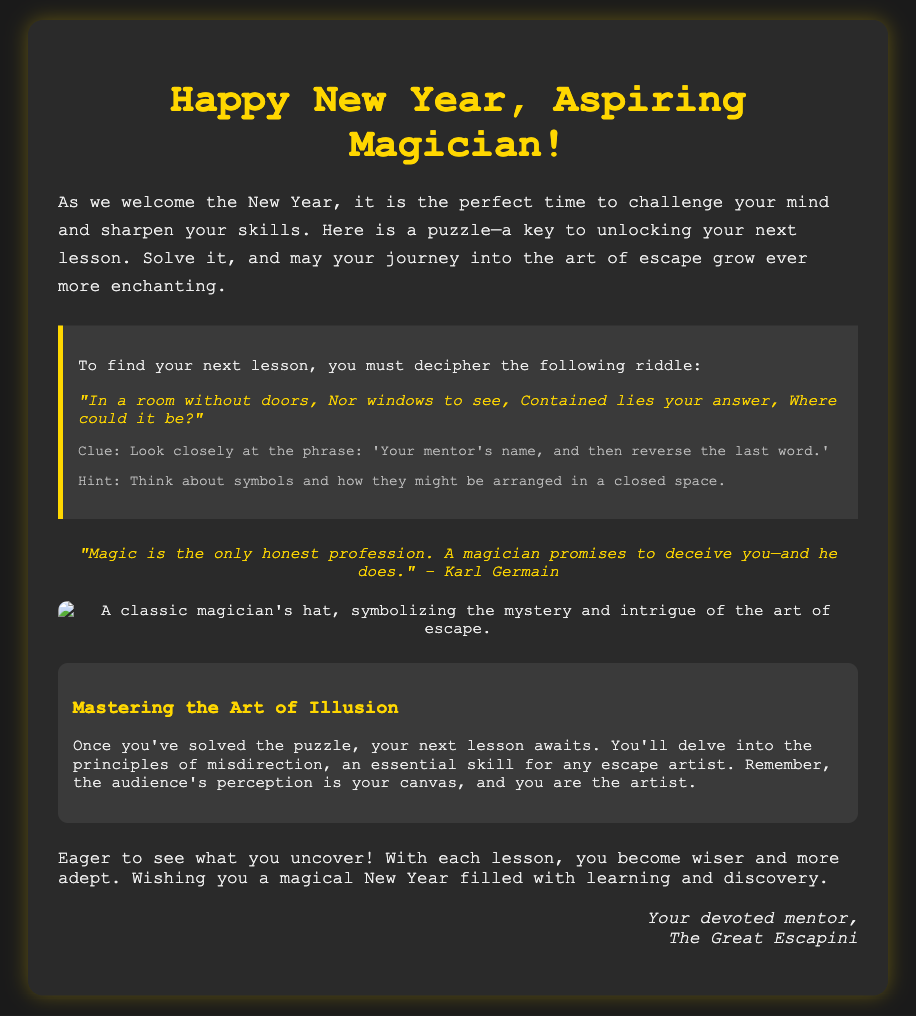What is the title of the card? The title is prominently displayed at the top of the card in large font.
Answer: Happy New Year, Aspiring Magician! What is the riddle presented in the puzzle? The riddle is found within the puzzle section of the card which challenges the reader.
Answer: "In a room without doors, Nor windows to see, Contained lies your answer, Where could it be?" What is the clue provided for solving the puzzle? The clue is meant to assist in deciphering the riddle presented earlier.
Answer: Look closely at the phrase: 'Your mentor's name, and then reverse the last word.' What is the quote included in the card? The quote is attributed to a well-known magician and adds depth to the card's message.
Answer: "Magic is the only honest profession. A magician promises to deceive you—and he does." – Karl Germain What lesson is mentioned after solving the puzzle? This lesson is the next step for the reader upon solving the challenge.
Answer: Mastering the Art of Illusion What is the color of the card’s background? The background color is essential for setting the overall tone of the card.
Answer: #1a1a1a Who is the signoff from? The signoff gives a personal touch and identifies the author of the message.
Answer: The Great Escapini What is the hint related to solving the puzzle? The hint serves as additional guidance for deciphering the riddle effectively.
Answer: Think about symbols and how they might be arranged in a closed space What image is included in the card? The image enhances the visual appeal and relates to the theme of the card.
Answer: A classic magician's hat, symbolizing the mystery and intrigue of the art of escape 